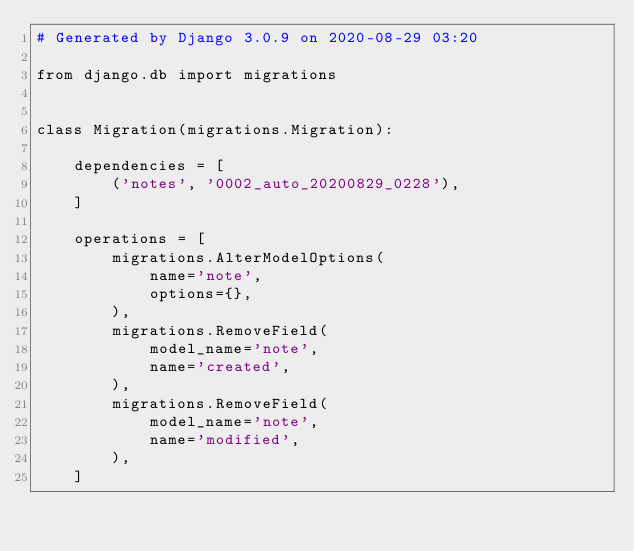<code> <loc_0><loc_0><loc_500><loc_500><_Python_># Generated by Django 3.0.9 on 2020-08-29 03:20

from django.db import migrations


class Migration(migrations.Migration):

    dependencies = [
        ('notes', '0002_auto_20200829_0228'),
    ]

    operations = [
        migrations.AlterModelOptions(
            name='note',
            options={},
        ),
        migrations.RemoveField(
            model_name='note',
            name='created',
        ),
        migrations.RemoveField(
            model_name='note',
            name='modified',
        ),
    ]
</code> 